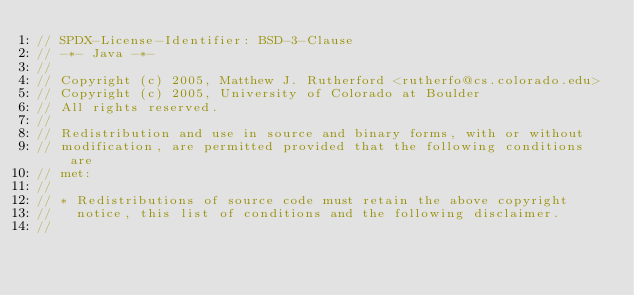Convert code to text. <code><loc_0><loc_0><loc_500><loc_500><_Java_>// SPDX-License-Identifier: BSD-3-Clause
// -*- Java -*-
//
// Copyright (c) 2005, Matthew J. Rutherford <rutherfo@cs.colorado.edu>
// Copyright (c) 2005, University of Colorado at Boulder
// All rights reserved.
//
// Redistribution and use in source and binary forms, with or without
// modification, are permitted provided that the following conditions are
// met:
//
// * Redistributions of source code must retain the above copyright
//   notice, this list of conditions and the following disclaimer.
//</code> 